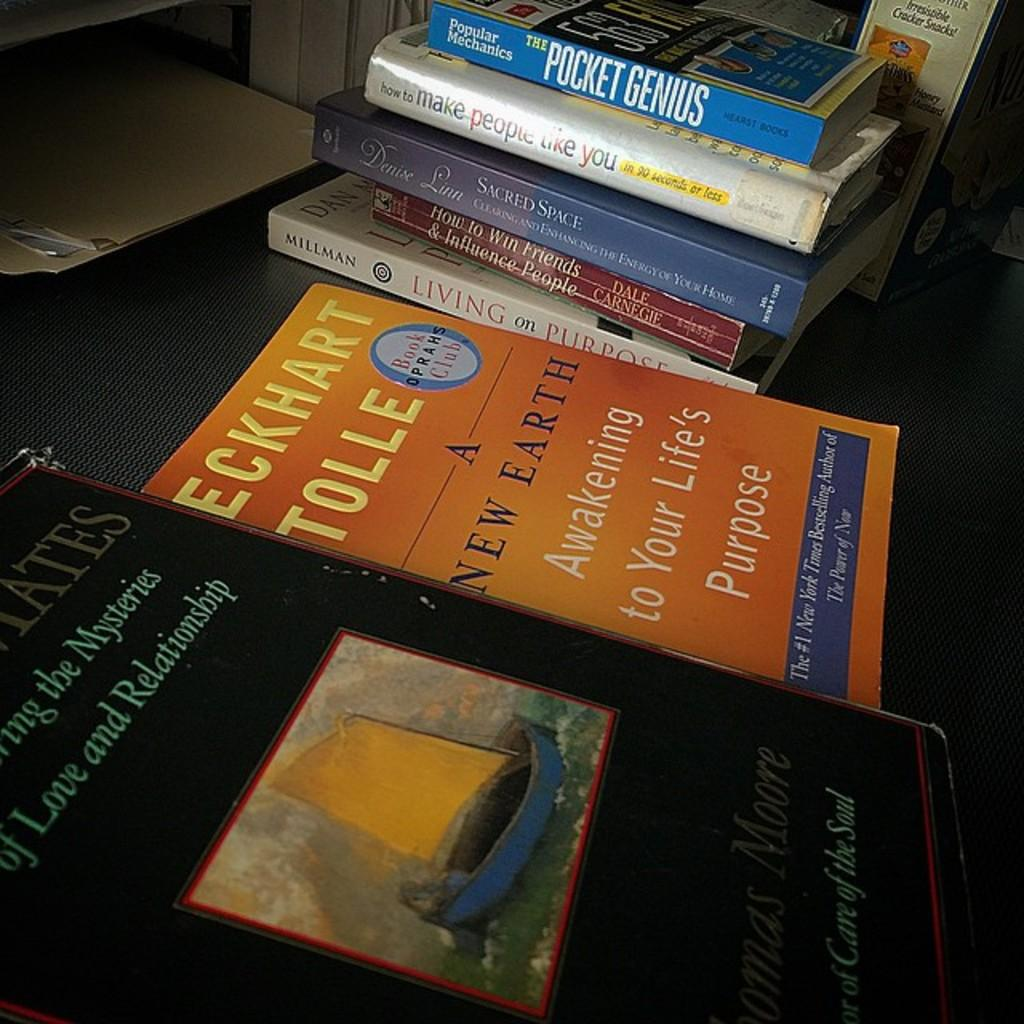Provide a one-sentence caption for the provided image. A collection of self help and personal improvement books by people like Dale Carnegie and Eckhart Tolle are displayed on a table. 